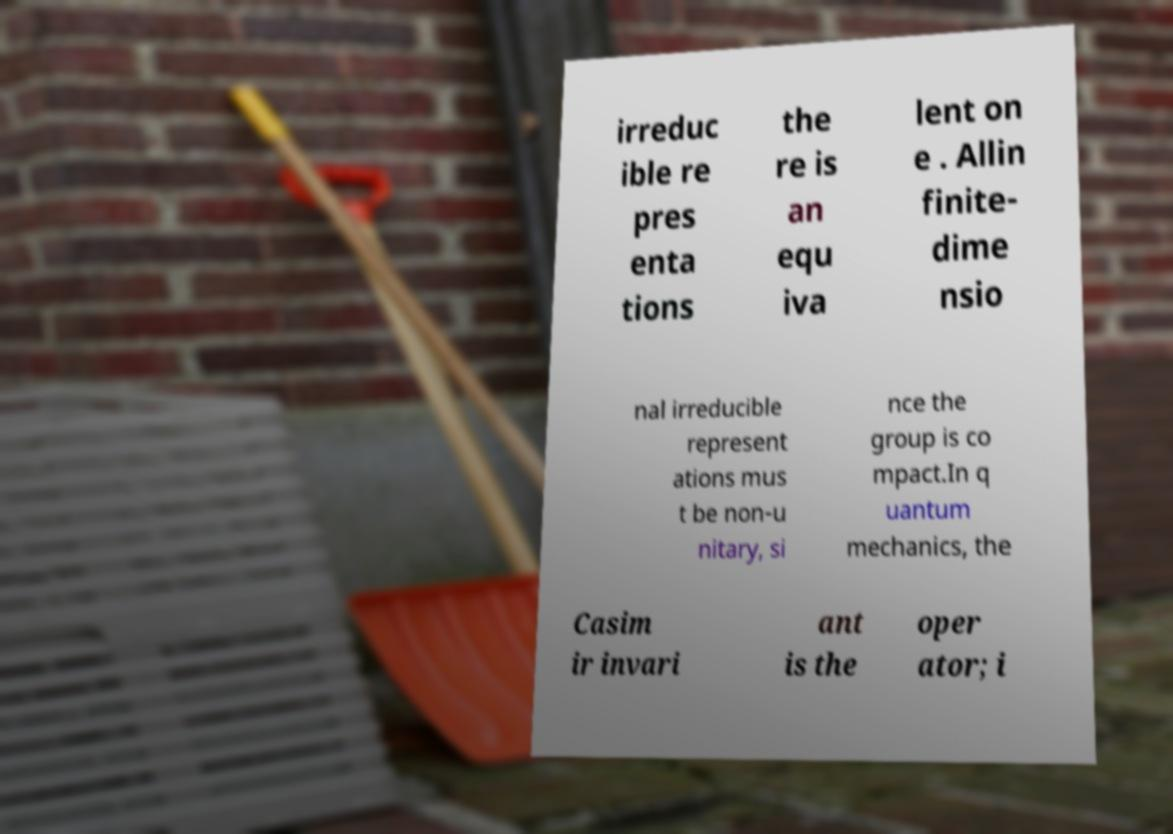Please read and relay the text visible in this image. What does it say? irreduc ible re pres enta tions the re is an equ iva lent on e . Allin finite- dime nsio nal irreducible represent ations mus t be non-u nitary, si nce the group is co mpact.In q uantum mechanics, the Casim ir invari ant is the oper ator; i 